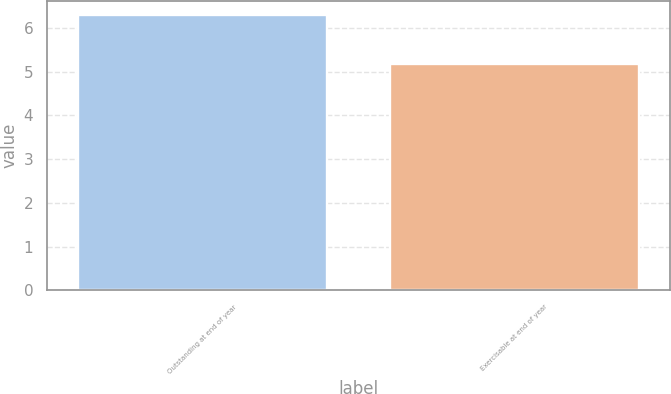<chart> <loc_0><loc_0><loc_500><loc_500><bar_chart><fcel>Outstanding at end of year<fcel>Exercisable at end of year<nl><fcel>6.3<fcel>5.18<nl></chart> 